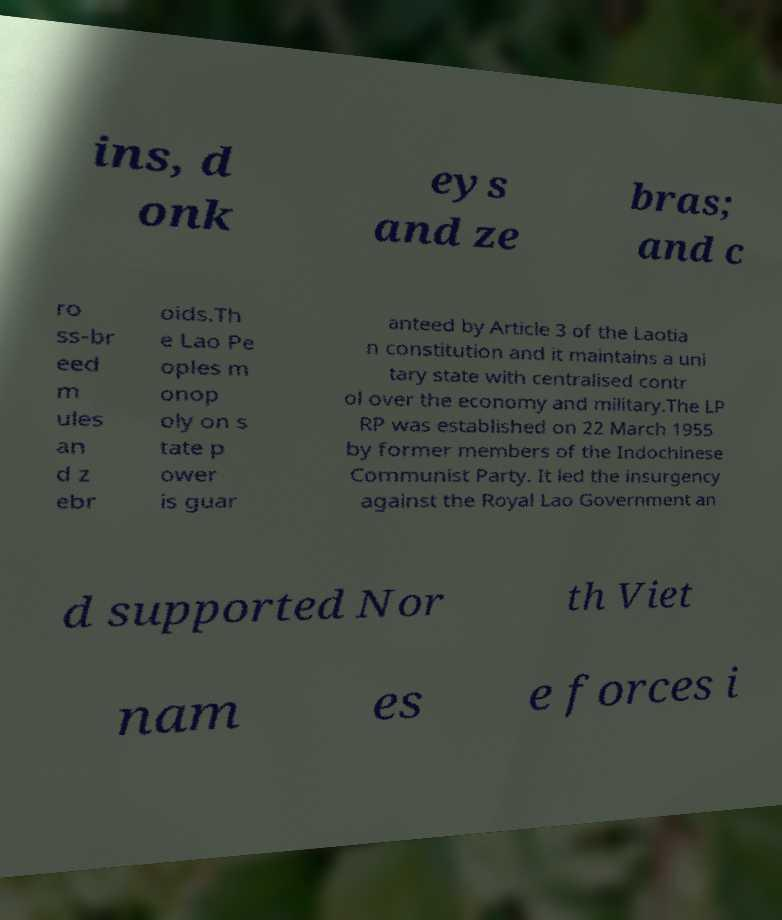Could you assist in decoding the text presented in this image and type it out clearly? ins, d onk eys and ze bras; and c ro ss-br eed m ules an d z ebr oids.Th e Lao Pe oples m onop oly on s tate p ower is guar anteed by Article 3 of the Laotia n constitution and it maintains a uni tary state with centralised contr ol over the economy and military.The LP RP was established on 22 March 1955 by former members of the Indochinese Communist Party. It led the insurgency against the Royal Lao Government an d supported Nor th Viet nam es e forces i 